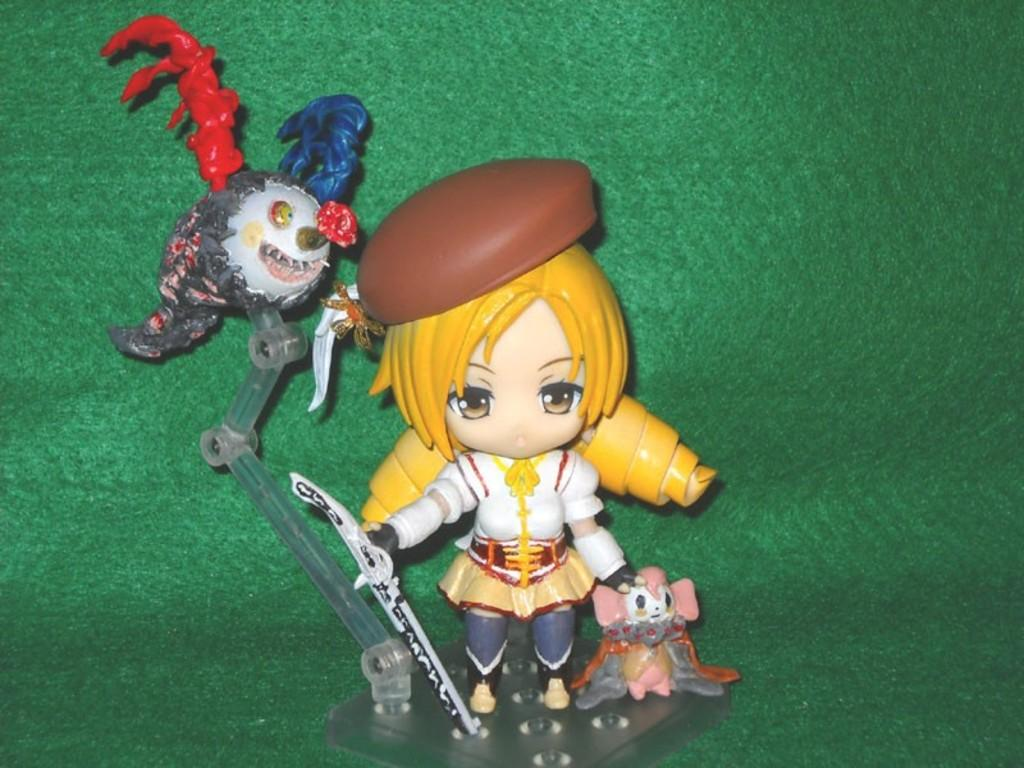What objects are present in the image? There are toys in the image. What is the color of the surface on which the toys are placed? The toys are on a green surface. How many seats are available for the toys in the image? There is no mention of seats in the image; the toys are simply placed on a green surface. 